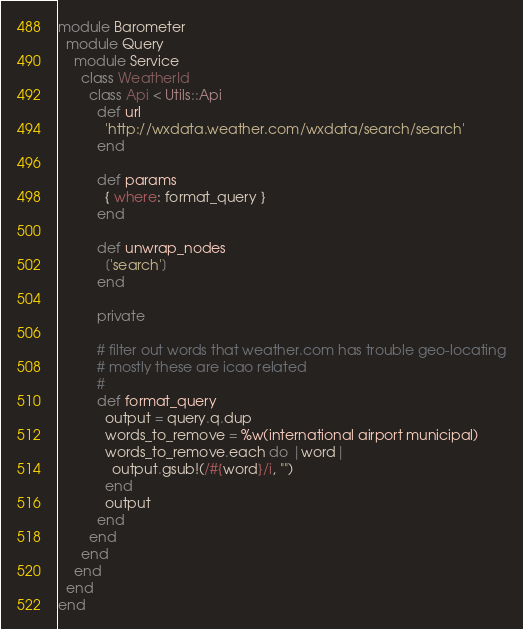<code> <loc_0><loc_0><loc_500><loc_500><_Ruby_>module Barometer
  module Query
    module Service
      class WeatherId
        class Api < Utils::Api
          def url
            'http://wxdata.weather.com/wxdata/search/search'
          end

          def params
            { where: format_query }
          end

          def unwrap_nodes
            ['search']
          end

          private

          # filter out words that weather.com has trouble geo-locating
          # mostly these are icao related
          #
          def format_query
            output = query.q.dup
            words_to_remove = %w(international airport municipal)
            words_to_remove.each do |word|
              output.gsub!(/#{word}/i, "")
            end
            output
          end
        end
      end
    end
  end
end
</code> 